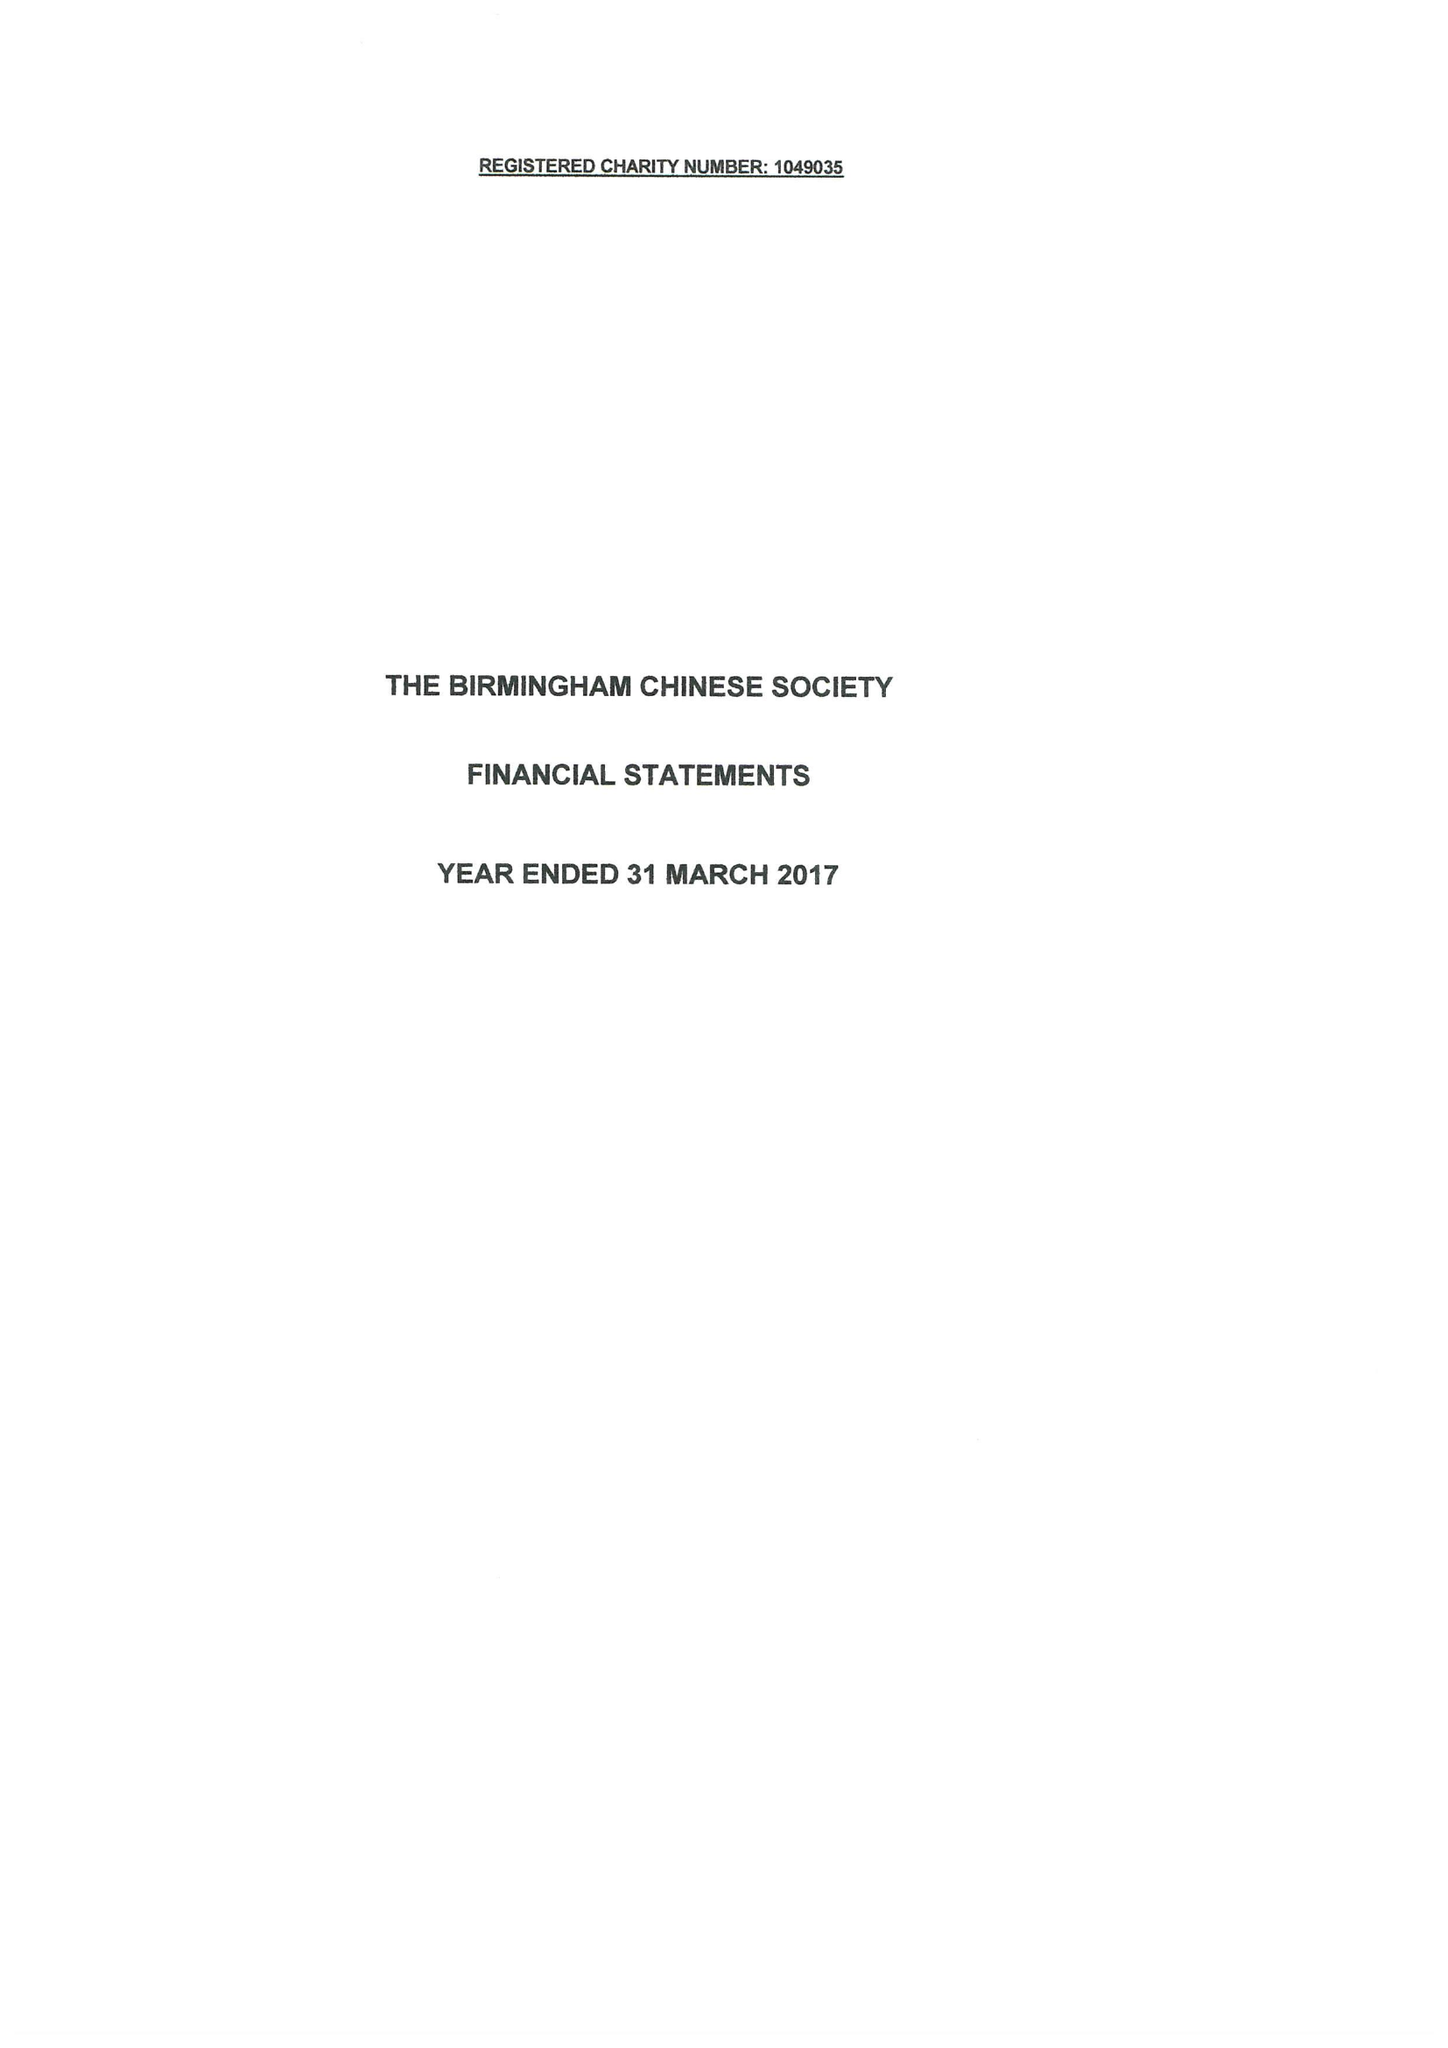What is the value for the income_annually_in_british_pounds?
Answer the question using a single word or phrase. 51637.00 